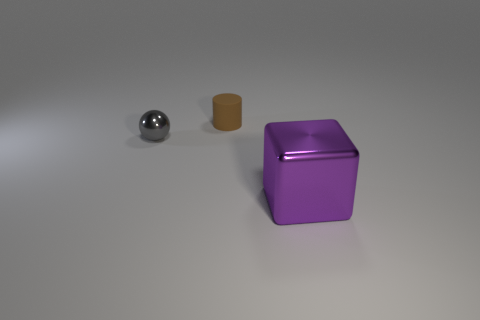Add 1 cyan rubber cylinders. How many objects exist? 4 Subtract all cylinders. How many objects are left? 2 Subtract all brown balls. Subtract all brown cubes. How many balls are left? 1 Subtract all tiny blue metal things. Subtract all purple cubes. How many objects are left? 2 Add 2 tiny brown matte things. How many tiny brown matte things are left? 3 Add 2 large purple blocks. How many large purple blocks exist? 3 Subtract 0 red spheres. How many objects are left? 3 Subtract 1 cylinders. How many cylinders are left? 0 